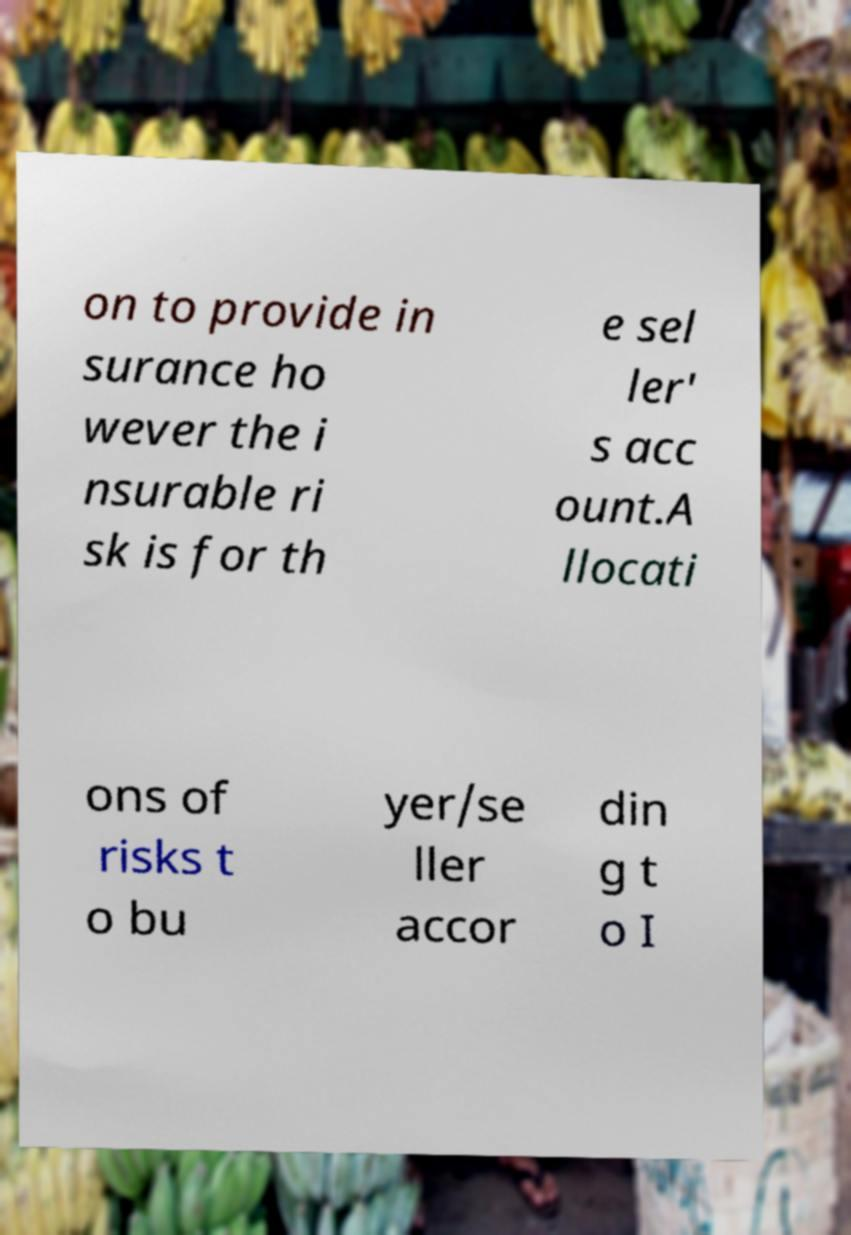Could you assist in decoding the text presented in this image and type it out clearly? on to provide in surance ho wever the i nsurable ri sk is for th e sel ler' s acc ount.A llocati ons of risks t o bu yer/se ller accor din g t o I 